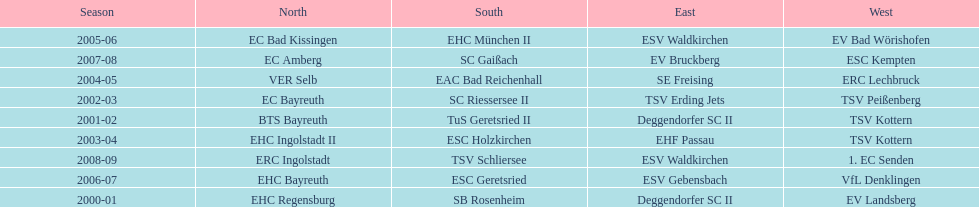The last team to win the west? 1. EC Senden. 